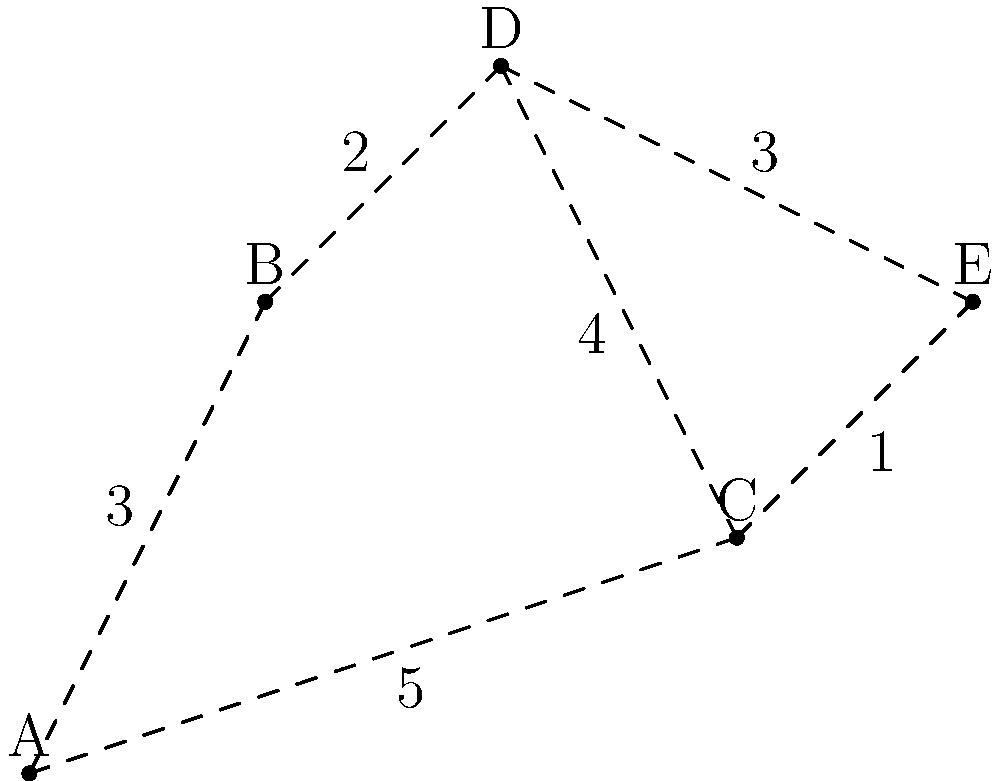In a nighttime search and rescue operation, your team needs to establish the most reliable communication network between all members. The graph represents the terrain, where nodes are team positions and edge weights indicate communication reliability (higher is better). What is the sum of the weights in the minimum spanning tree that ensures the most reliable overall connection? To find the minimum spanning tree (MST) that ensures the most reliable overall connection, we'll use Kruskal's algorithm, which works well for sparse graphs. The algorithm selects edges in descending order of weight (since higher weight means better reliability in this case) while avoiding cycles.

Step 1: Sort the edges by weight in descending order:
(C-E, 5), (C-D, 4), (A-B, 3), (D-E, 3), (B-D, 2), (C-E, 1)

Step 2: Select edges and add to the MST if they don't create a cycle:
1. (C-E, 5): Add to MST
2. (C-D, 4): Add to MST
3. (A-B, 3): Add to MST
4. (D-E, 3): Skip (creates a cycle)
5. (B-D, 2): Add to MST

The algorithm stops here as we have connected all 5 nodes with 4 edges.

Step 3: Calculate the sum of the weights in the MST:
5 + 4 + 3 + 2 = 14

Therefore, the sum of the weights in the minimum spanning tree that ensures the most reliable overall connection is 14.
Answer: 14 